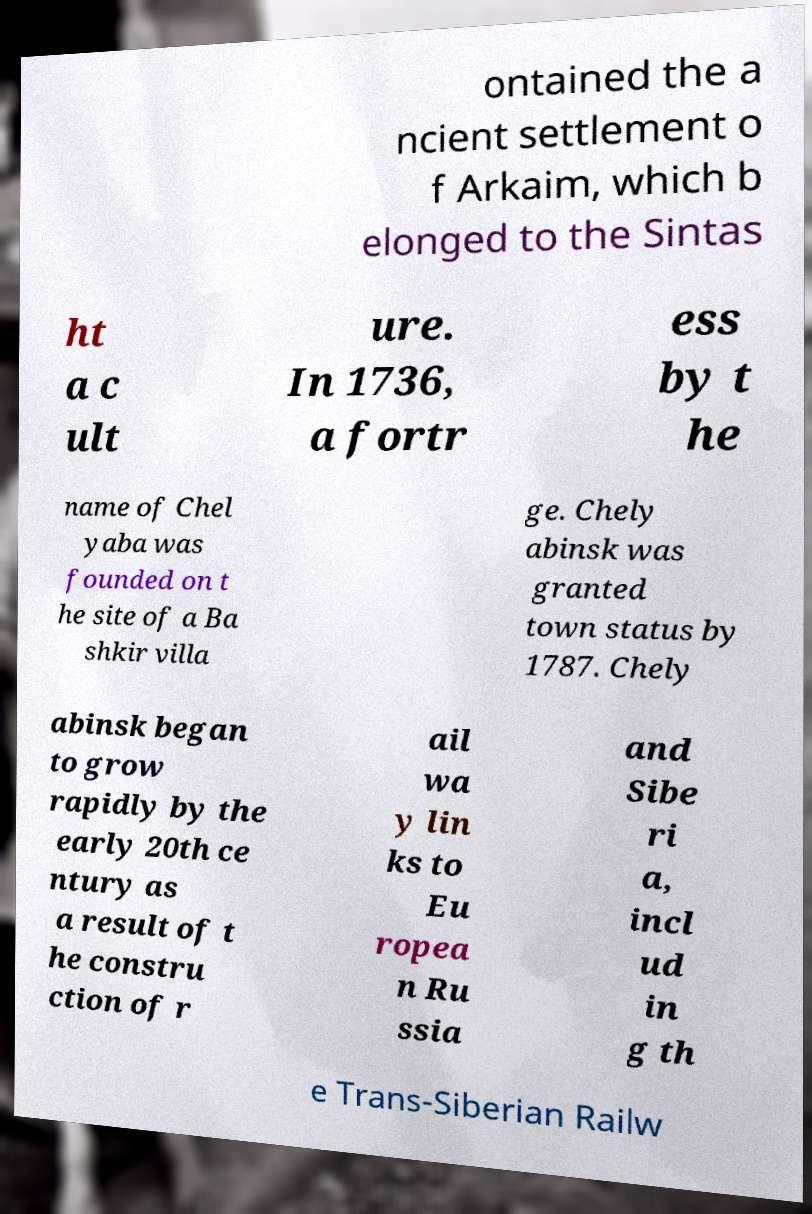Please identify and transcribe the text found in this image. ontained the a ncient settlement o f Arkaim, which b elonged to the Sintas ht a c ult ure. In 1736, a fortr ess by t he name of Chel yaba was founded on t he site of a Ba shkir villa ge. Chely abinsk was granted town status by 1787. Chely abinsk began to grow rapidly by the early 20th ce ntury as a result of t he constru ction of r ail wa y lin ks to Eu ropea n Ru ssia and Sibe ri a, incl ud in g th e Trans-Siberian Railw 